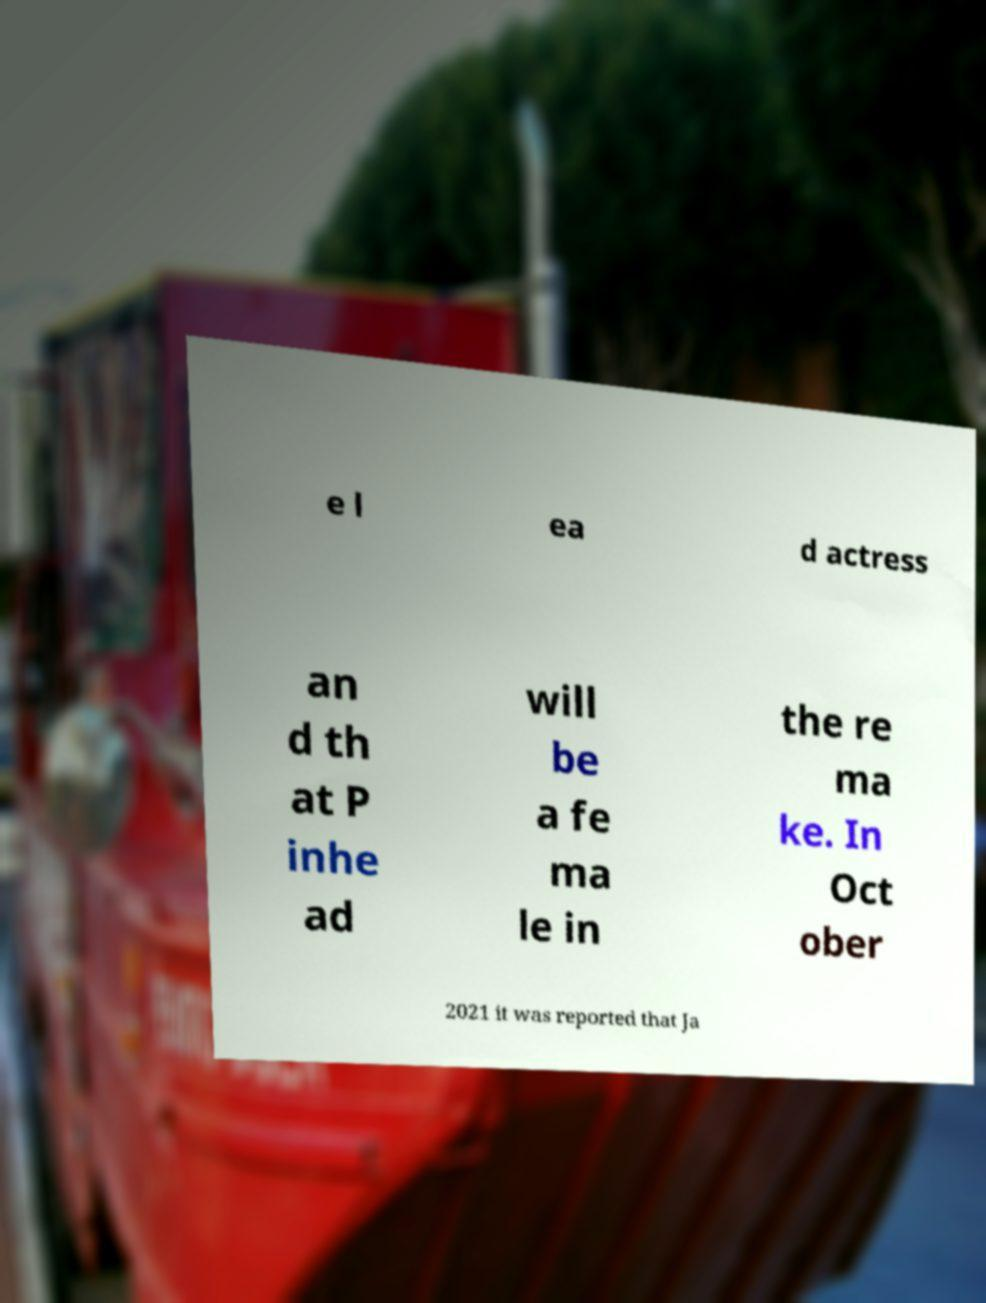Please read and relay the text visible in this image. What does it say? e l ea d actress an d th at P inhe ad will be a fe ma le in the re ma ke. In Oct ober 2021 it was reported that Ja 